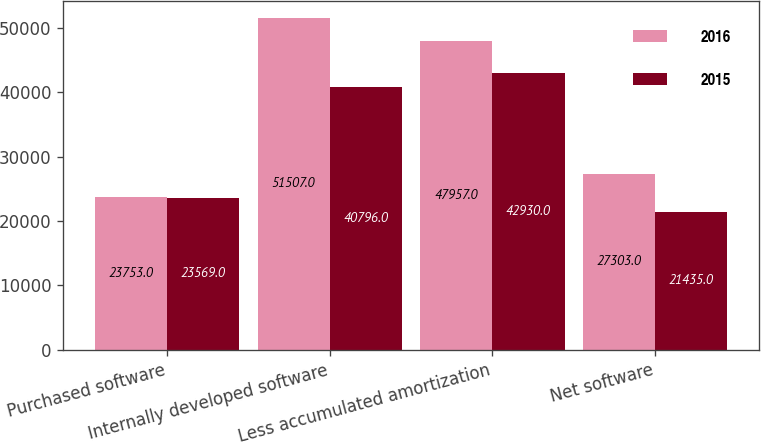Convert chart. <chart><loc_0><loc_0><loc_500><loc_500><stacked_bar_chart><ecel><fcel>Purchased software<fcel>Internally developed software<fcel>Less accumulated amortization<fcel>Net software<nl><fcel>2016<fcel>23753<fcel>51507<fcel>47957<fcel>27303<nl><fcel>2015<fcel>23569<fcel>40796<fcel>42930<fcel>21435<nl></chart> 